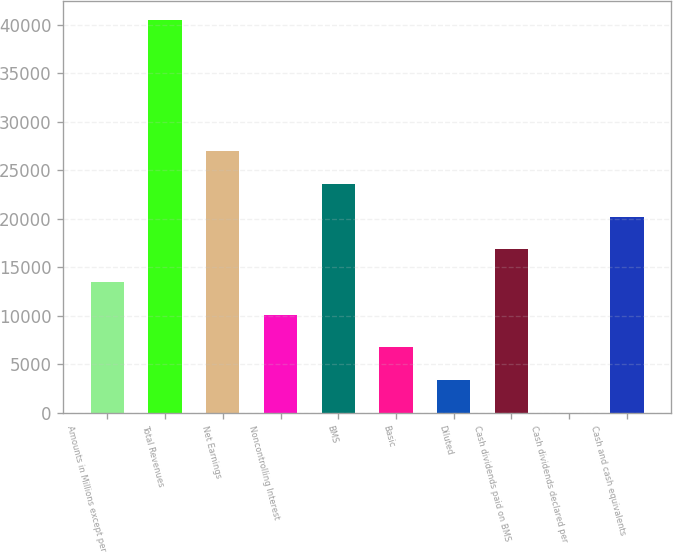Convert chart. <chart><loc_0><loc_0><loc_500><loc_500><bar_chart><fcel>Amounts in Millions except per<fcel>Total Revenues<fcel>Net Earnings<fcel>Noncontrolling Interest<fcel>BMS<fcel>Basic<fcel>Diluted<fcel>Cash dividends paid on BMS<fcel>Cash dividends declared per<fcel>Cash and cash equivalents<nl><fcel>13483.7<fcel>40448.1<fcel>26965.9<fcel>10113.2<fcel>23595.4<fcel>6742.63<fcel>3372.08<fcel>16854.3<fcel>1.53<fcel>20224.8<nl></chart> 